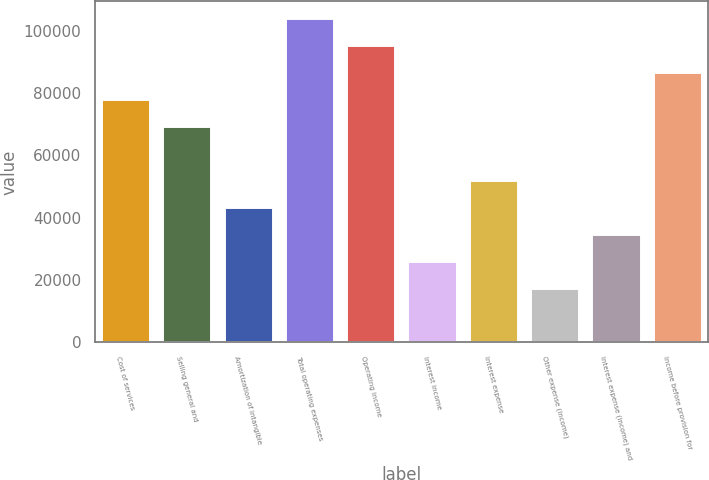Convert chart to OTSL. <chart><loc_0><loc_0><loc_500><loc_500><bar_chart><fcel>Cost of services<fcel>Selling general and<fcel>Amortization of intangible<fcel>Total operating expenses<fcel>Operating income<fcel>Interest income<fcel>Interest expense<fcel>Other expense (income)<fcel>Interest expense (income) and<fcel>Income before provision for<nl><fcel>78122.7<fcel>69442.4<fcel>43401.6<fcel>104164<fcel>95483.3<fcel>26041<fcel>52081.9<fcel>17360.8<fcel>34721.3<fcel>86803<nl></chart> 